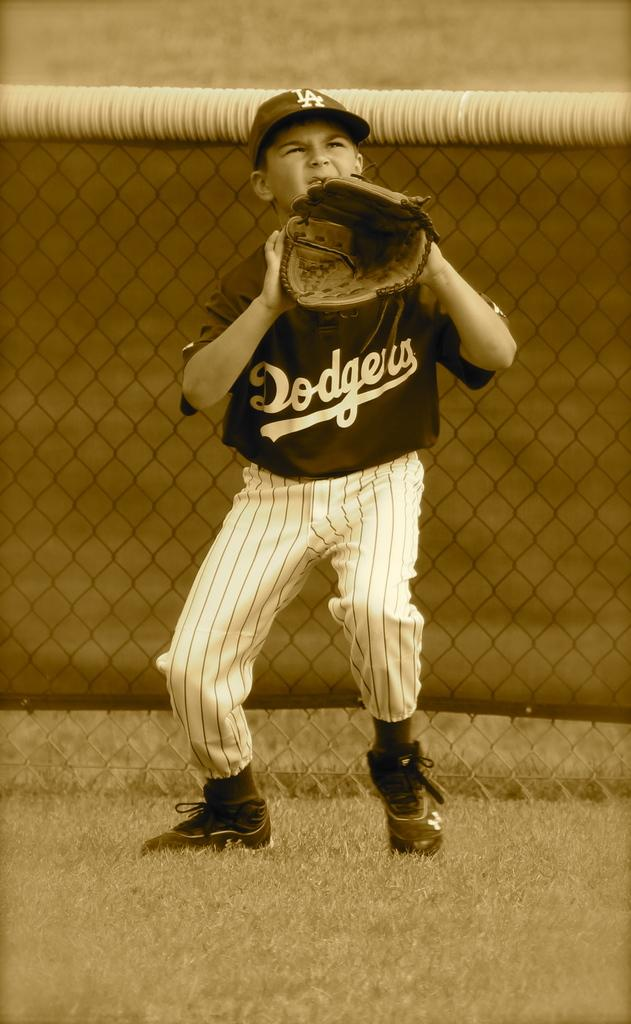<image>
Relay a brief, clear account of the picture shown. a person with Dodgers written on their shirt 